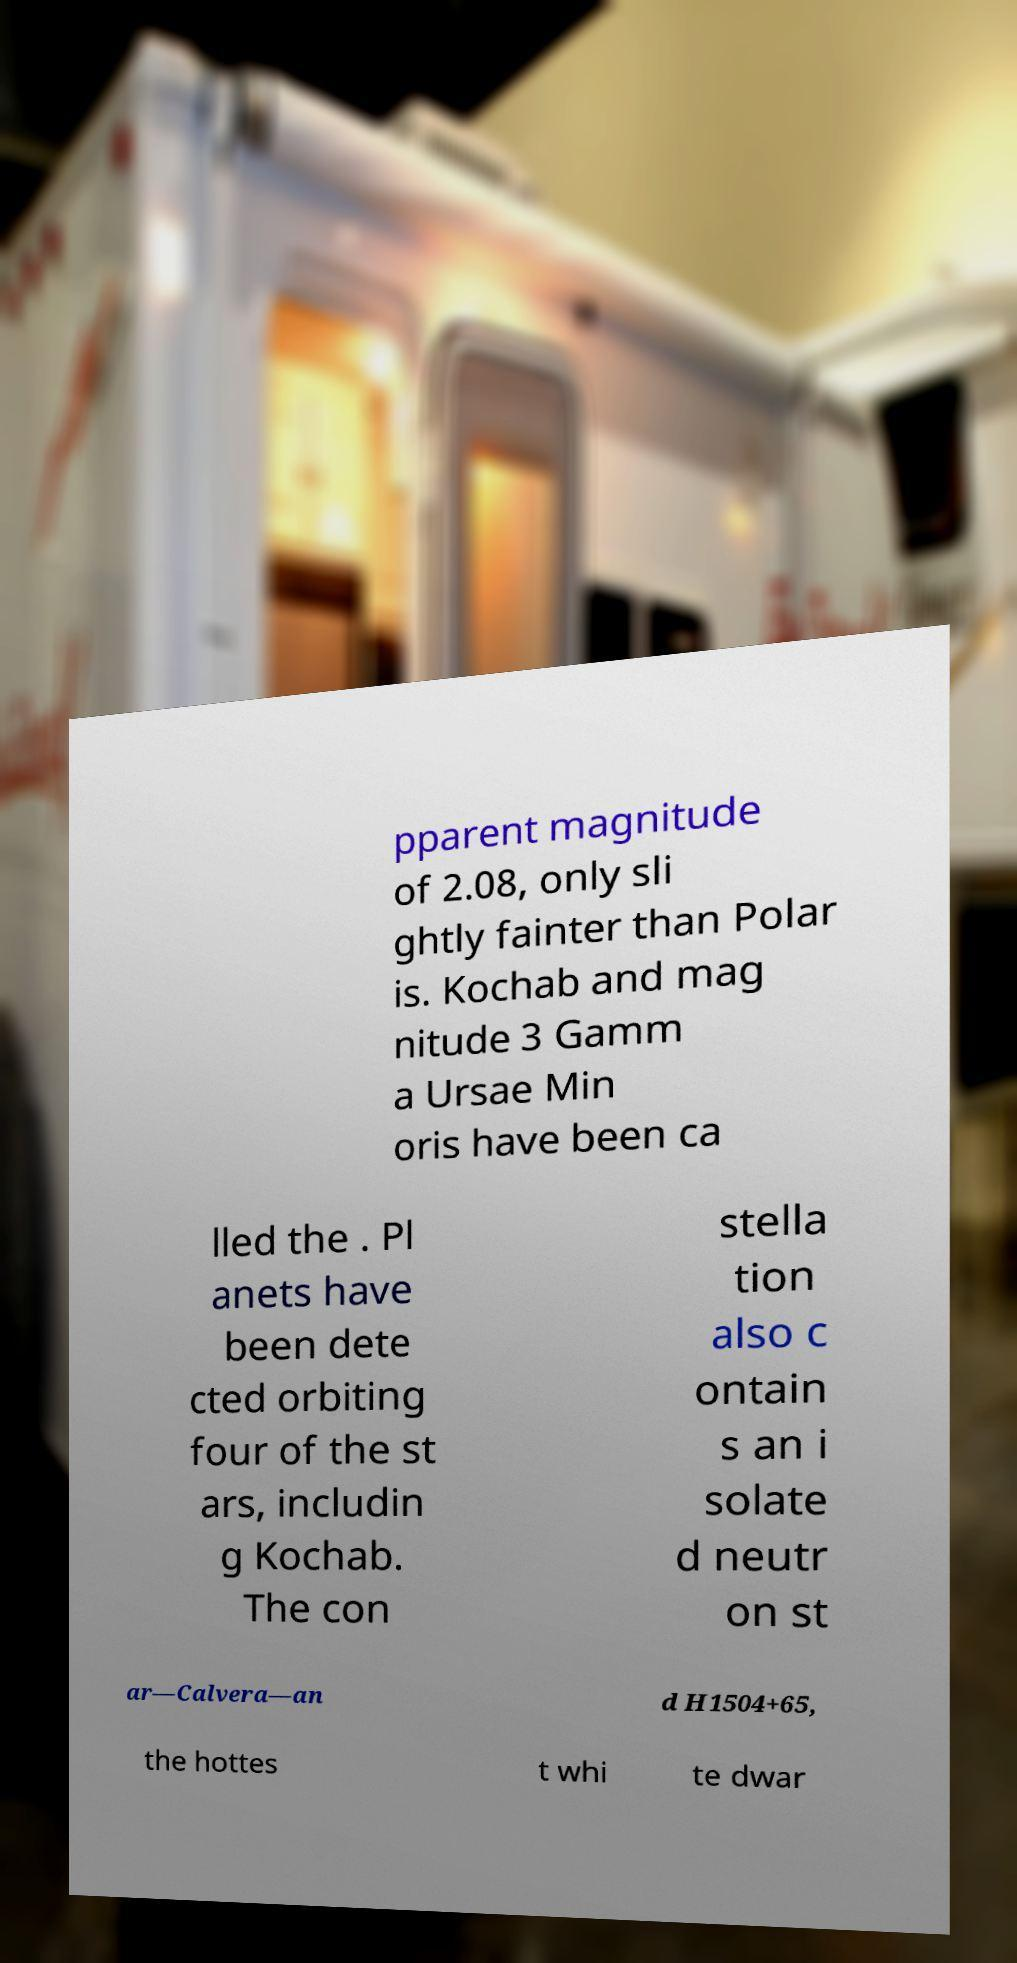I need the written content from this picture converted into text. Can you do that? pparent magnitude of 2.08, only sli ghtly fainter than Polar is. Kochab and mag nitude 3 Gamm a Ursae Min oris have been ca lled the . Pl anets have been dete cted orbiting four of the st ars, includin g Kochab. The con stella tion also c ontain s an i solate d neutr on st ar—Calvera—an d H1504+65, the hottes t whi te dwar 